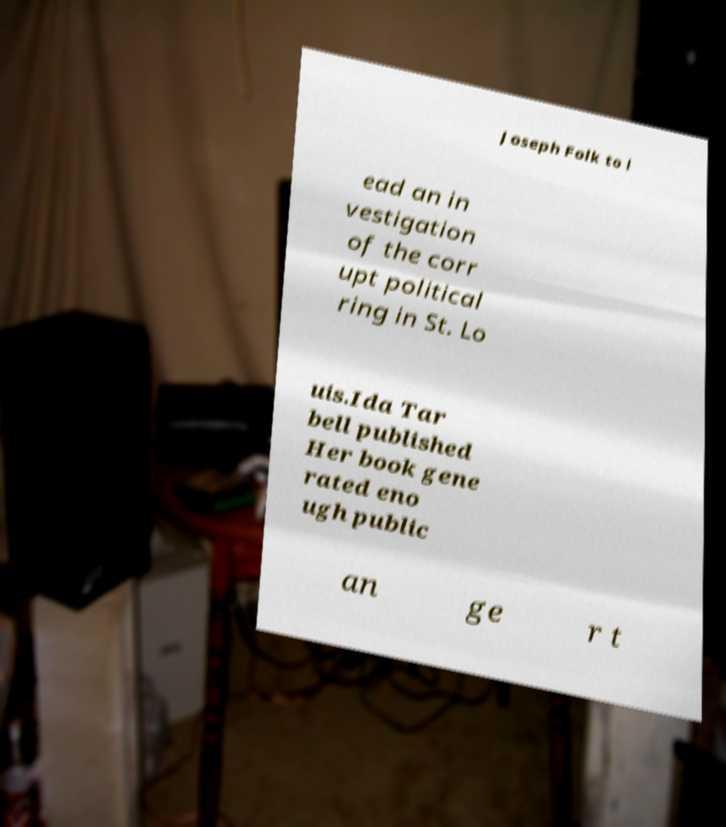What messages or text are displayed in this image? I need them in a readable, typed format. Joseph Folk to l ead an in vestigation of the corr upt political ring in St. Lo uis.Ida Tar bell published Her book gene rated eno ugh public an ge r t 